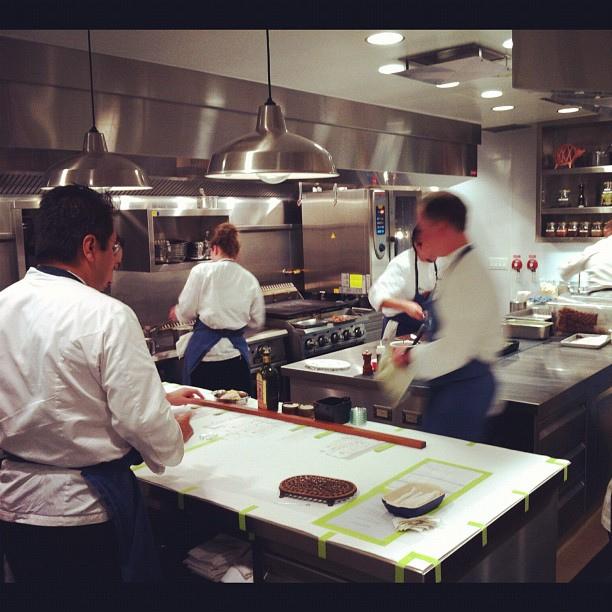What color is the woman's apron?
Be succinct. Blue. How many people are pictured?
Keep it brief. 5. How many lights hanging from the ceiling?
Write a very short answer. 2. What room is this?
Write a very short answer. Kitchen. 